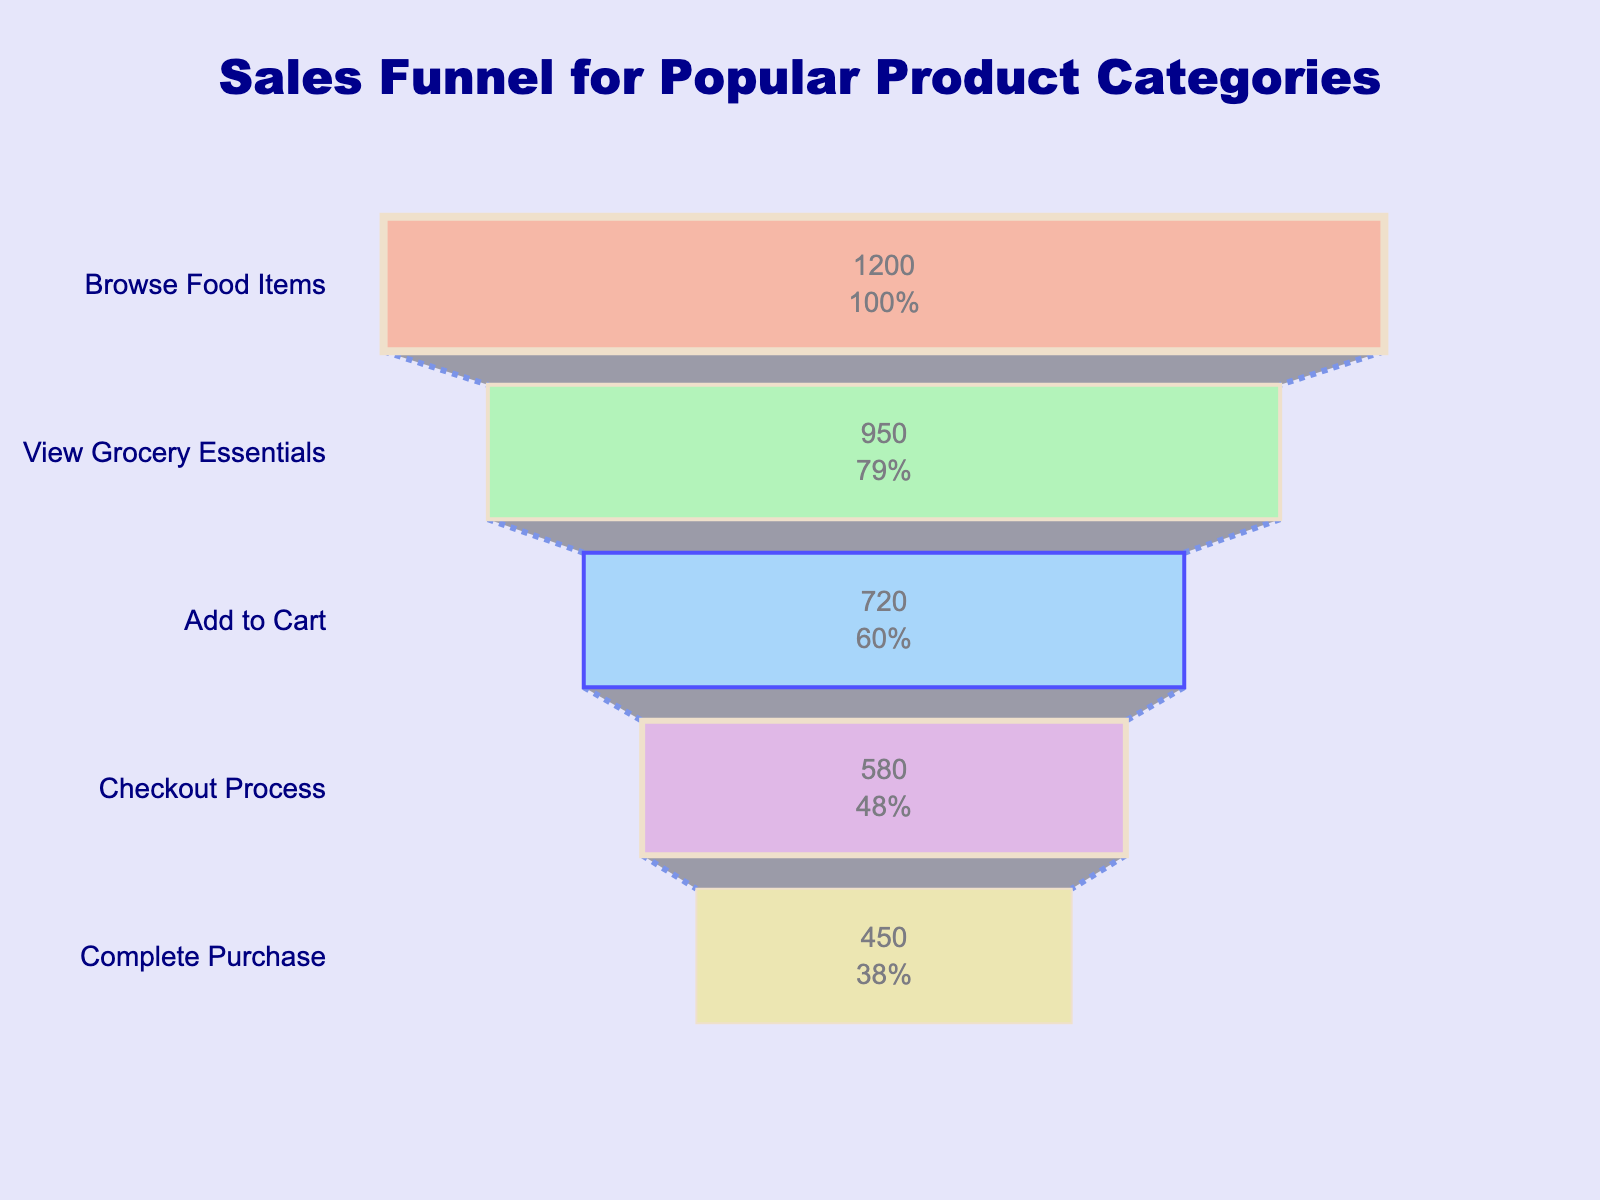What is the title of the funnel chart? The title of a chart is usually found at the top and gives you a summary of what the chart is about. In this case, the title is in bold and navy blue, and it reads: "Sales Funnel for Popular Product Categories".
Answer: Sales Funnel for Popular Product Categories What is the percentage of customers that proceed from "Browse Food Items" to the "View Grocery Essentials" stage? To find this percentage, we calculate the number of customers at the "View Grocery Essentials" stage as a proportion of those at the "Browse Food Items" stage. So, it is 950 / 1200 * 100.
Answer: 79.17% How many customers are there in the "Add to Cart" stage? The funnel chart will display numerical values for each stage inside the funnel slices. The value for the "Add to Cart" stage is displayed directly within the funnel segment.
Answer: 720 What is the color of the "Complete Purchase" stage, and why might this color be useful? The color of the "Complete Purchase" stage in the funnel chart is light khaki (often represented as #F0E68C). Colors in a funnel chart help differentiate between stages, making it easier to track the customer's journey visually.
Answer: Light khaki Which stage has the lowest number of customers, and how many customers are in that stage? By observing the funnel chart, it's easy to identify the stage with the smallest segment as the one with the lowest number of customers. Here, the "Complete Purchase" stage is the smallest. The number of customers in this stage is indicated inside the segment.
Answer: Complete Purchase, 450 What is the percentage drop from the "Add to Cart" stage to the "Checkout Process" stage? Calculate the percentage drop by taking the difference between the two stages and dividing it by the number of customers in the "Add to Cart" stage. So, (720 - 580) / 720 * 100.
Answer: 19.44% Compare the number of customers in the "Checkout Process" stage to those in the "Complete Purchase" stage. What is the difference? The funnel chart shows that there are 580 customers in the "Checkout Process" stage and 450 customers in the "Complete Purchase" stage. Subtract the latter from the former to find the difference.
Answer: 130 Which stage has a thick blue outline, and why is highlighting stages important in funnel charts? The "Add to Cart" stage has a thick blue outline. Highlighting helps draw attention to critical stages where significant customer drop-offs might occur, allowing store owners to focus on optimizing these stages.
Answer: Add to Cart What does the connector between the stages signify, and what is its visual style? The connectors in a funnel chart typically indicate the flow of customers between stages. In this chart, the connector is a dotted blue line, symbolizing the transition or drop-off between the stages.
Answer: Transition, dotted blue line Which stage has the largest percentage of initial customers progressing to it, and what is this percentage? To identify this, we compare the percentage values displayed inside the segments. The stage with the highest percentage among the initial customers is the "View Grocery Essentials" stage. The percentage displayed is the highest compared to others.
Answer: View Grocery Essentials, 79.17% 